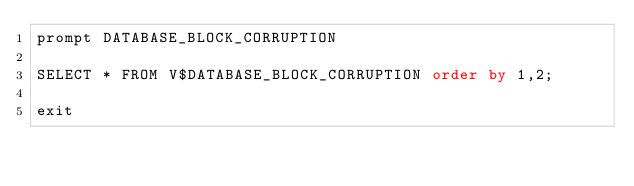Convert code to text. <code><loc_0><loc_0><loc_500><loc_500><_SQL_>prompt DATABASE_BLOCK_CORRUPTION

SELECT * FROM V$DATABASE_BLOCK_CORRUPTION order by 1,2;

exit
</code> 